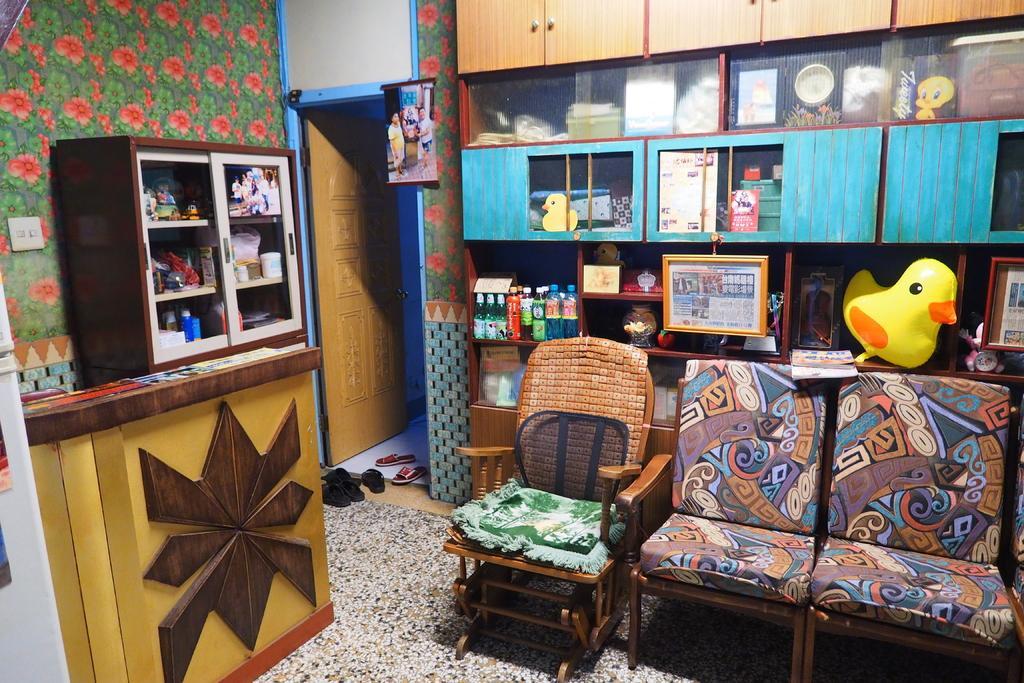How would you summarize this image in a sentence or two? This picture describes about interior of the room in this we can find couple of chairs and slippers, and also we can find couple of bottles shields toys in the racks. 